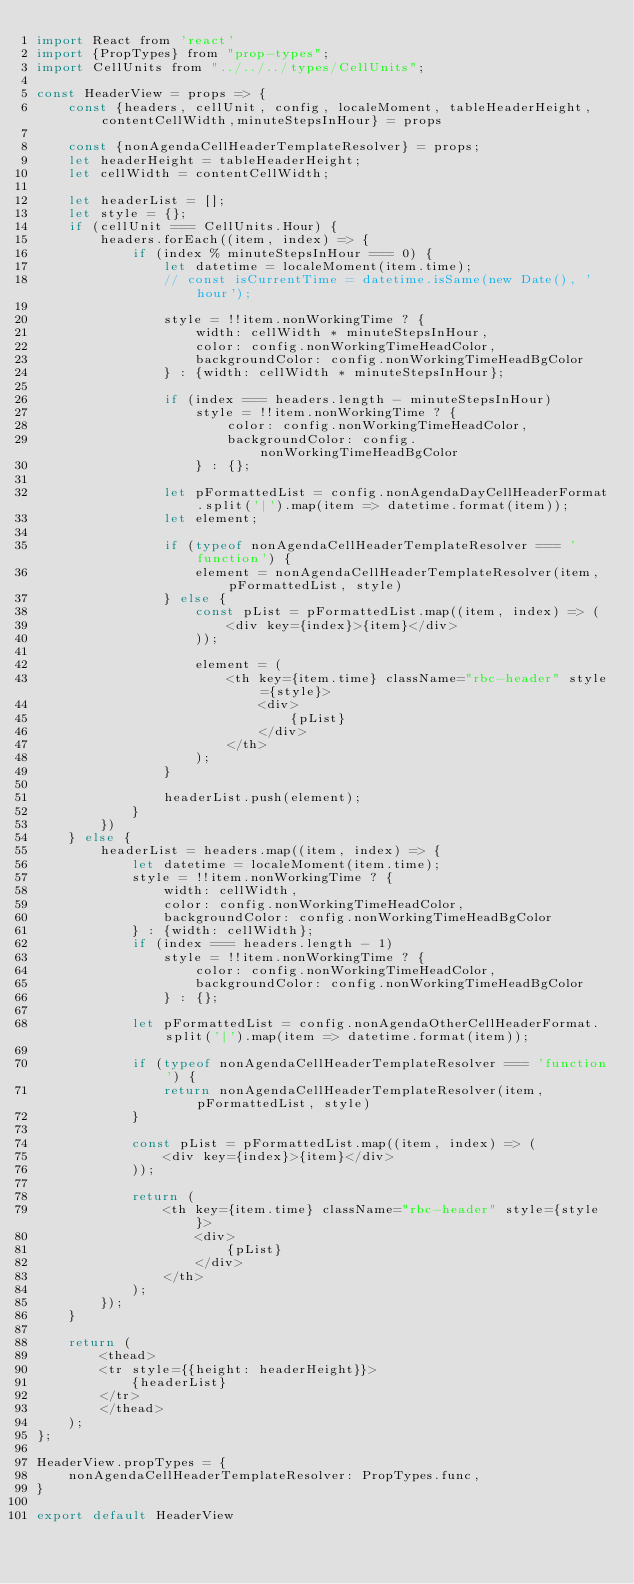<code> <loc_0><loc_0><loc_500><loc_500><_JavaScript_>import React from 'react'
import {PropTypes} from "prop-types";
import CellUnits from "../../../types/CellUnits";

const HeaderView = props => {
    const {headers, cellUnit, config, localeMoment, tableHeaderHeight,contentCellWidth,minuteStepsInHour} = props

    const {nonAgendaCellHeaderTemplateResolver} = props;
    let headerHeight = tableHeaderHeight;
    let cellWidth = contentCellWidth;

    let headerList = [];
    let style = {};
    if (cellUnit === CellUnits.Hour) {
        headers.forEach((item, index) => {
            if (index % minuteStepsInHour === 0) {
                let datetime = localeMoment(item.time);
                // const isCurrentTime = datetime.isSame(new Date(), 'hour');

                style = !!item.nonWorkingTime ? {
                    width: cellWidth * minuteStepsInHour,
                    color: config.nonWorkingTimeHeadColor,
                    backgroundColor: config.nonWorkingTimeHeadBgColor
                } : {width: cellWidth * minuteStepsInHour};

                if (index === headers.length - minuteStepsInHour)
                    style = !!item.nonWorkingTime ? {
                        color: config.nonWorkingTimeHeadColor,
                        backgroundColor: config.nonWorkingTimeHeadBgColor
                    } : {};

                let pFormattedList = config.nonAgendaDayCellHeaderFormat.split('|').map(item => datetime.format(item));
                let element;

                if (typeof nonAgendaCellHeaderTemplateResolver === 'function') {
                    element = nonAgendaCellHeaderTemplateResolver(item, pFormattedList, style)
                } else {
                    const pList = pFormattedList.map((item, index) => (
                        <div key={index}>{item}</div>
                    ));

                    element = (
                        <th key={item.time} className="rbc-header" style={style}>
                            <div>
                                {pList}
                            </div>
                        </th>
                    );
                }

                headerList.push(element);
            }
        })
    } else {
        headerList = headers.map((item, index) => {
            let datetime = localeMoment(item.time);
            style = !!item.nonWorkingTime ? {
                width: cellWidth,
                color: config.nonWorkingTimeHeadColor,
                backgroundColor: config.nonWorkingTimeHeadBgColor
            } : {width: cellWidth};
            if (index === headers.length - 1)
                style = !!item.nonWorkingTime ? {
                    color: config.nonWorkingTimeHeadColor,
                    backgroundColor: config.nonWorkingTimeHeadBgColor
                } : {};

            let pFormattedList = config.nonAgendaOtherCellHeaderFormat.split('|').map(item => datetime.format(item));

            if (typeof nonAgendaCellHeaderTemplateResolver === 'function') {
                return nonAgendaCellHeaderTemplateResolver(item, pFormattedList, style)
            }

            const pList = pFormattedList.map((item, index) => (
                <div key={index}>{item}</div>
            ));

            return (
                <th key={item.time} className="rbc-header" style={style}>
                    <div>
                        {pList}
                    </div>
                </th>
            );
        });
    }

    return (
        <thead>
        <tr style={{height: headerHeight}}>
            {headerList}
        </tr>
        </thead>
    );
};

HeaderView.propTypes = {
    nonAgendaCellHeaderTemplateResolver: PropTypes.func,
}

export default HeaderView
</code> 